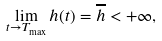<formula> <loc_0><loc_0><loc_500><loc_500>\lim _ { t \rightarrow T _ { \max } } h ( t ) = \overline { h } < + \infty ,</formula> 